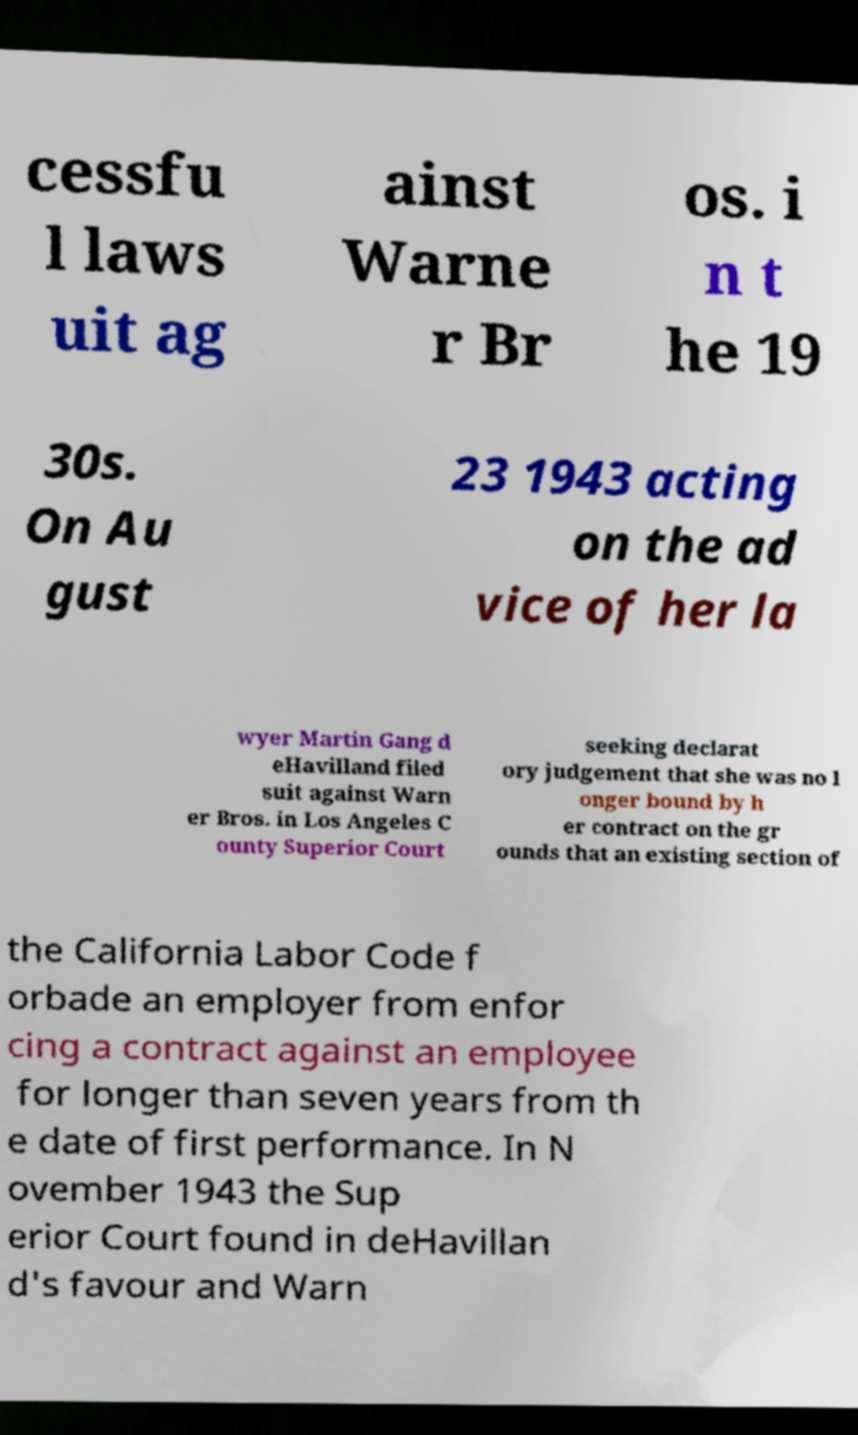There's text embedded in this image that I need extracted. Can you transcribe it verbatim? cessfu l laws uit ag ainst Warne r Br os. i n t he 19 30s. On Au gust 23 1943 acting on the ad vice of her la wyer Martin Gang d eHavilland filed suit against Warn er Bros. in Los Angeles C ounty Superior Court seeking declarat ory judgement that she was no l onger bound by h er contract on the gr ounds that an existing section of the California Labor Code f orbade an employer from enfor cing a contract against an employee for longer than seven years from th e date of first performance. In N ovember 1943 the Sup erior Court found in deHavillan d's favour and Warn 